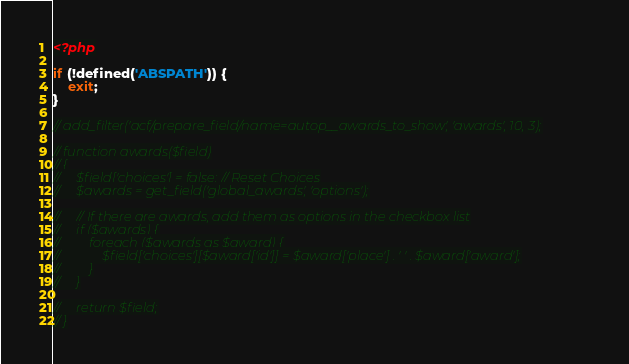Convert code to text. <code><loc_0><loc_0><loc_500><loc_500><_PHP_><?php

if (!defined('ABSPATH')) {
    exit;
}

// add_filter('acf/prepare_field/name=autop__awards_to_show', 'awards', 10, 3);

// function awards($field)
// {
//     $field['choices'] = false; // Reset Choices
//     $awards = get_field('global_awards', 'options');

//     // If there are awards, add them as options in the checkbox list
//     if ($awards) {
//         foreach ($awards as $award) {
//             $field['choices'][$award['id']] = $award['place'] . ' ' . $award['award'];
//         }
//     }

//     return $field;
// }
</code> 